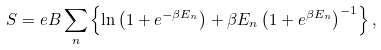<formula> <loc_0><loc_0><loc_500><loc_500>S = e B \sum _ { n } \left \{ \ln \left ( 1 + e ^ { - \beta E _ { n } } \right ) + \beta E _ { n } \left ( 1 + e ^ { \beta E _ { n } } \right ) ^ { - 1 } \right \} ,</formula> 